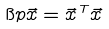Convert formula to latex. <formula><loc_0><loc_0><loc_500><loc_500>\i p { \vec { x } } = \vec { x } ^ { \, T } \vec { x }</formula> 